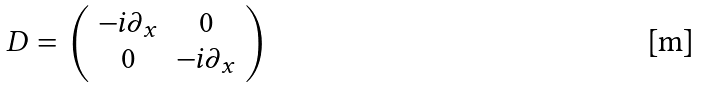<formula> <loc_0><loc_0><loc_500><loc_500>D = \left ( \begin{array} { c c } - i \partial _ { x } & 0 \\ 0 & - i \partial _ { x } \end{array} \right )</formula> 